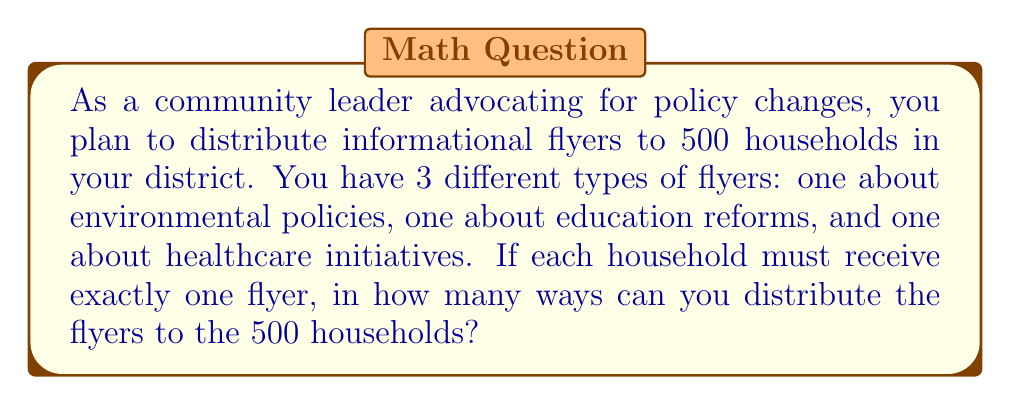Solve this math problem. Let's approach this step-by-step:

1) This is a problem of distributing distinct objects (different types of flyers) into distinct containers (households).

2) For each household, we have 3 choices of flyers to give.

3) We need to make this choice independently for each of the 500 households.

4) This scenario follows the multiplication principle of counting.

5) The total number of ways to distribute the flyers is:

   $$3 \times 3 \times 3 \times ... \times 3$$ (500 times)

6) This can be written as an exponent:

   $$3^{500}$$

7) This number is extremely large and would be impractical to calculate exactly.

8) However, we can express it in scientific notation:

   $$3^{500} \approx 3.27 \times 10^{238}$$
Answer: $3^{500}$ 